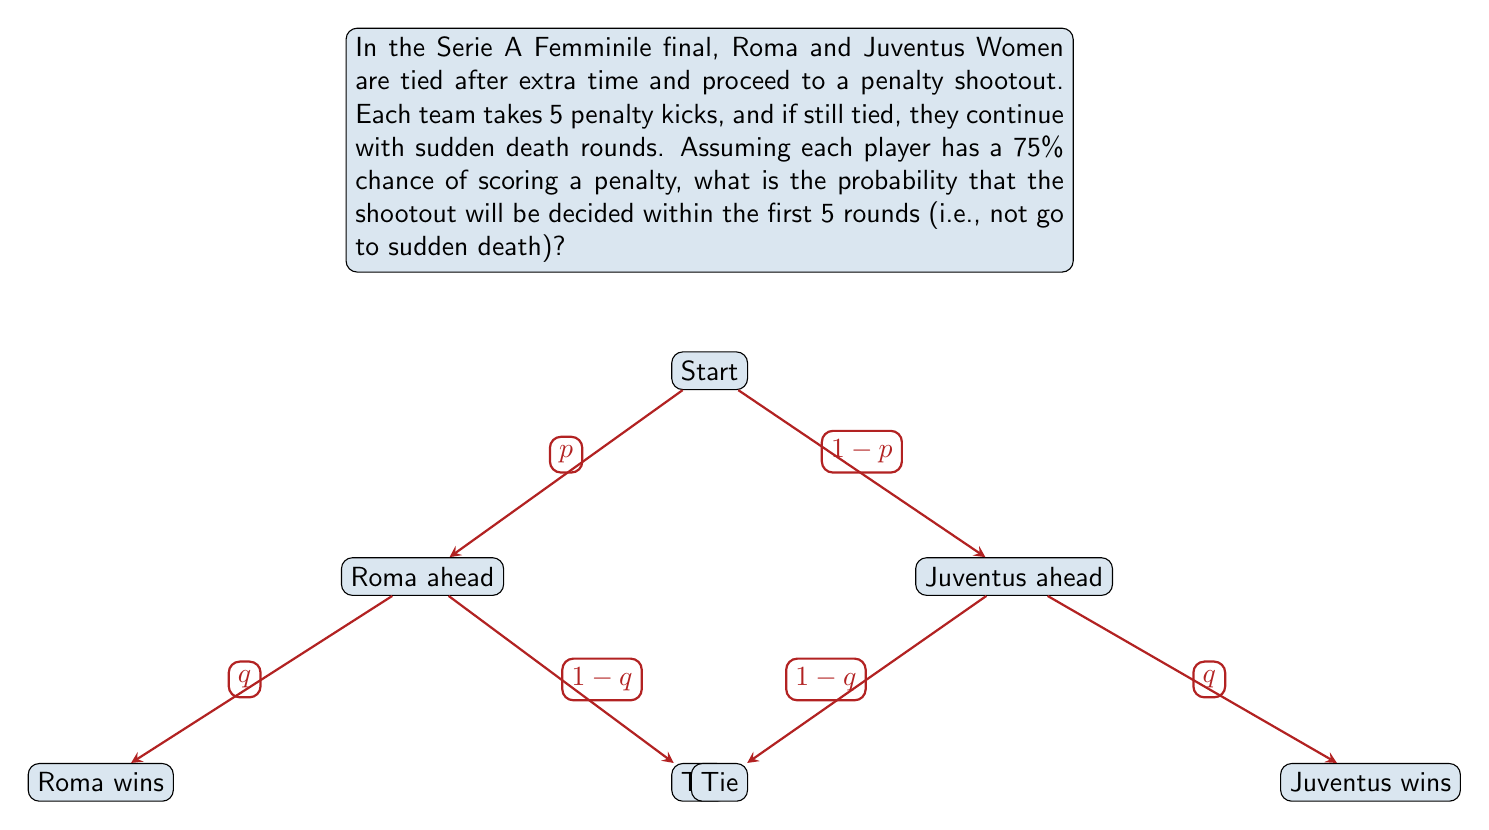Give your solution to this math problem. Let's approach this step-by-step:

1) First, we need to calculate the probability of a team being ahead after 5 rounds. Let's call this probability $p$.

2) For a team to be ahead after 5 rounds, they need to score more goals than the other team. This can happen in various ways:
   5-4, 5-3, 5-2, 5-1, 5-0, 4-3, 4-2, 4-1, 4-0, 3-2, 3-1, 3-0, 2-1, 2-0, 1-0

3) We can calculate this using the binomial probability formula:

   $$p = \sum_{i=0}^4 \sum_{j=i+1}^5 \binom{5}{j}\binom{5}{i}(0.75)^j(0.25)^{5-j}(0.75)^i(0.25)^{5-i}$$

4) Calculating this (you can use a calculator or computer for this), we get:
   $p \approx 0.4194$

5) Now, the probability of the shootout being decided in the first 5 rounds is the probability of either team being ahead after 5 rounds:

   $$P(\text{decided in 5 rounds}) = p + p = 2p$$

6) Substituting our calculated value:

   $$P(\text{decided in 5 rounds}) = 2 * 0.4194 = 0.8388$$

Therefore, the probability that the shootout will be decided within the first 5 rounds is approximately 0.8388 or 83.88%.
Answer: $0.8388$ or $83.88\%$ 